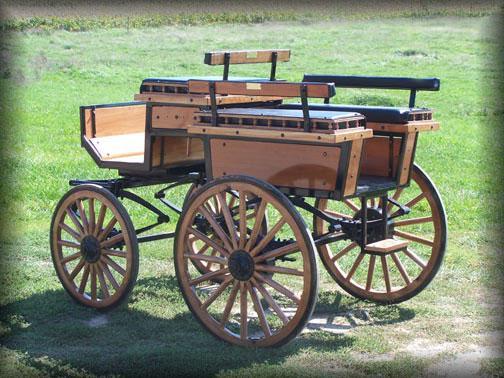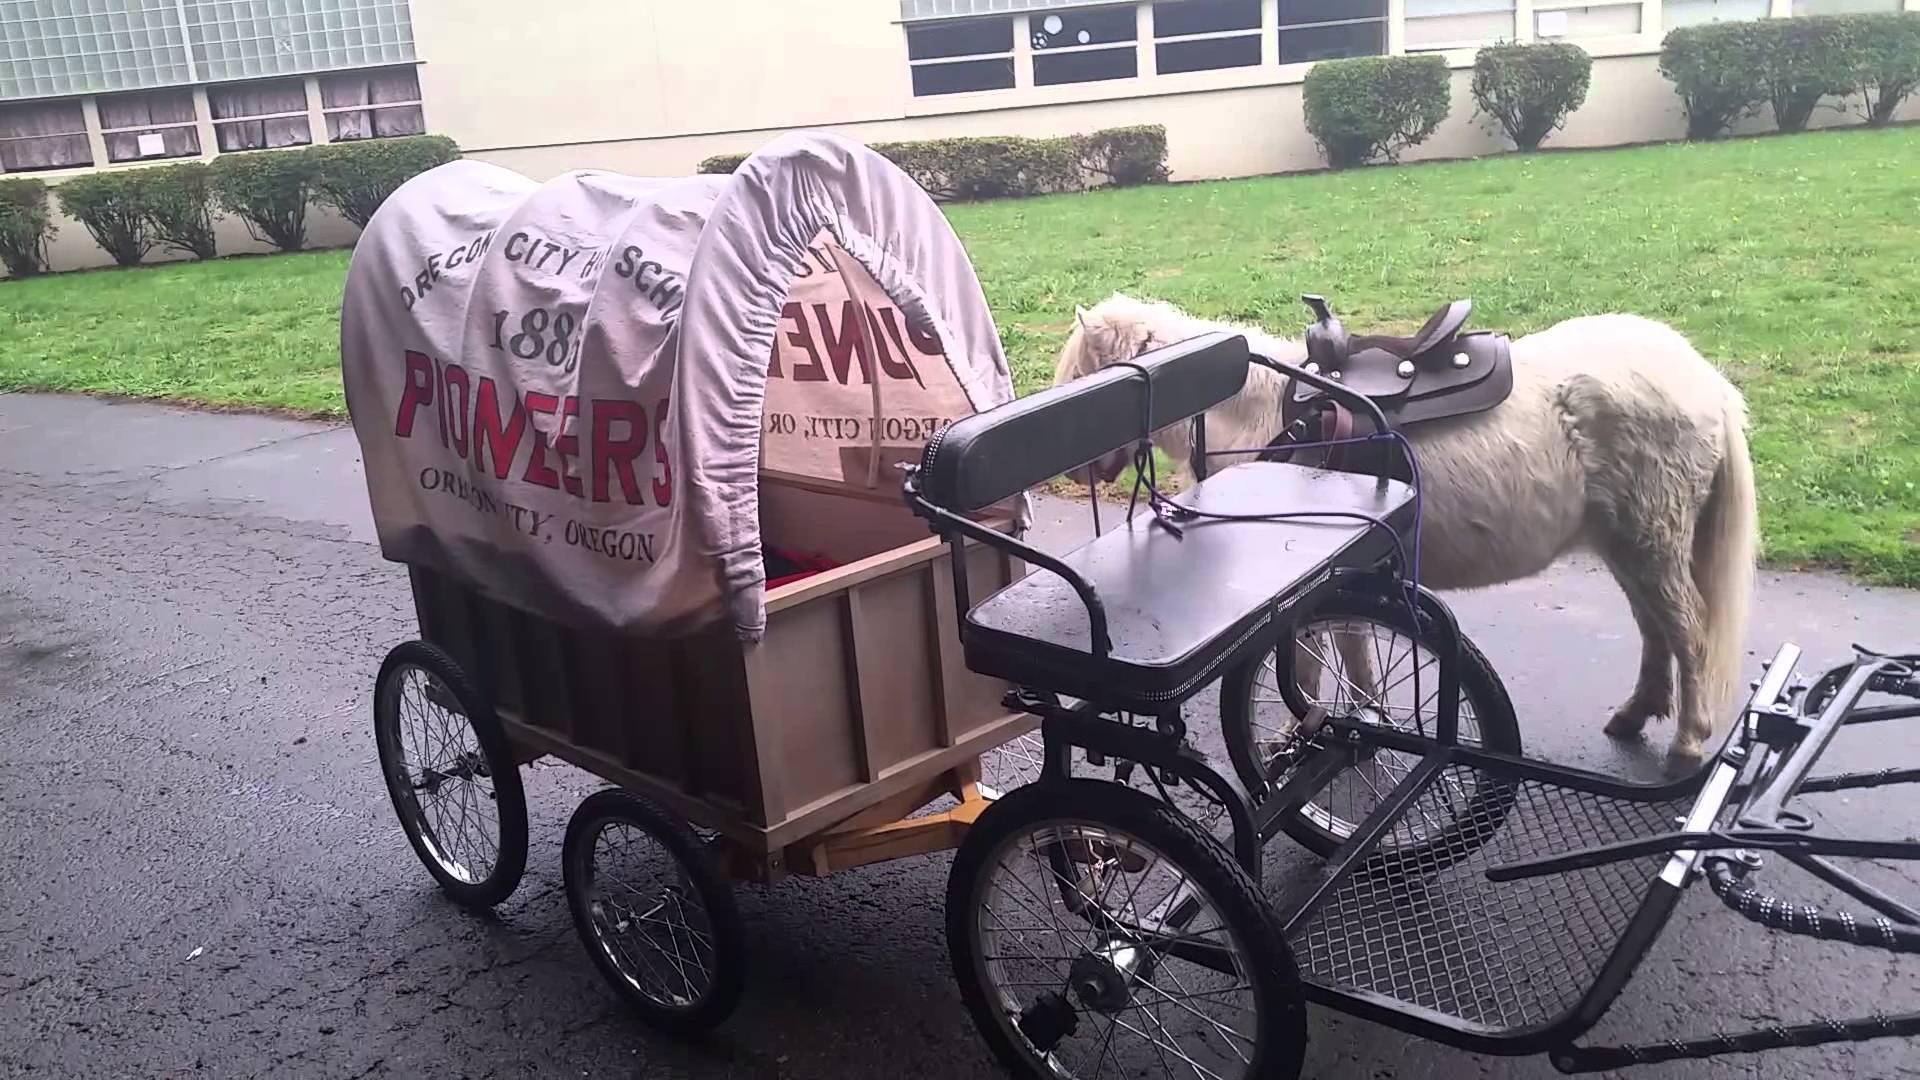The first image is the image on the left, the second image is the image on the right. For the images displayed, is the sentence "There is a human riding a carriage." factually correct? Answer yes or no. No. 